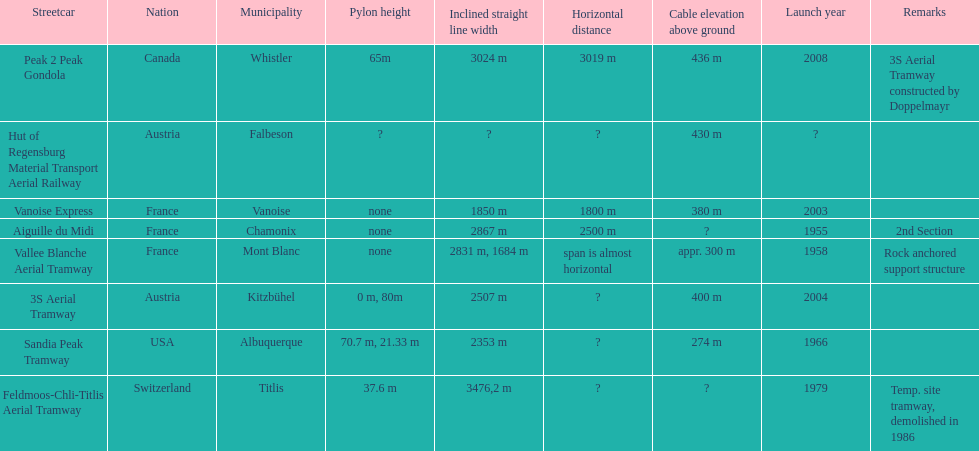Was the sandia peak tramway commencement before or after the 3s aerial tramway? Before. 